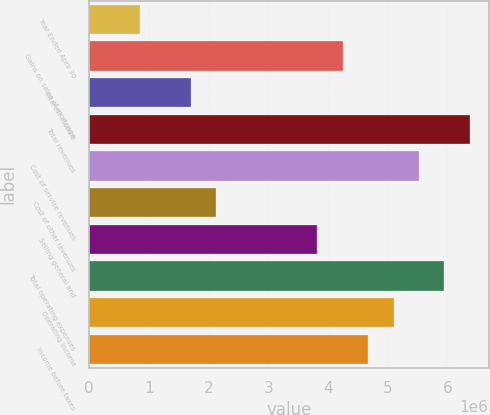Convert chart to OTSL. <chart><loc_0><loc_0><loc_500><loc_500><bar_chart><fcel>Year Ended April 30<fcel>Gains on sales of mortgage<fcel>Interest income<fcel>Total revenues<fcel>Cost of service revenues<fcel>Cost of other revenues<fcel>Selling general and<fcel>Total operating expenses<fcel>Operating income<fcel>Income before taxes<nl><fcel>849578<fcel>4.24788e+06<fcel>1.69915e+06<fcel>6.37182e+06<fcel>5.52224e+06<fcel>2.12394e+06<fcel>3.82309e+06<fcel>5.94703e+06<fcel>5.09746e+06<fcel>4.67267e+06<nl></chart> 